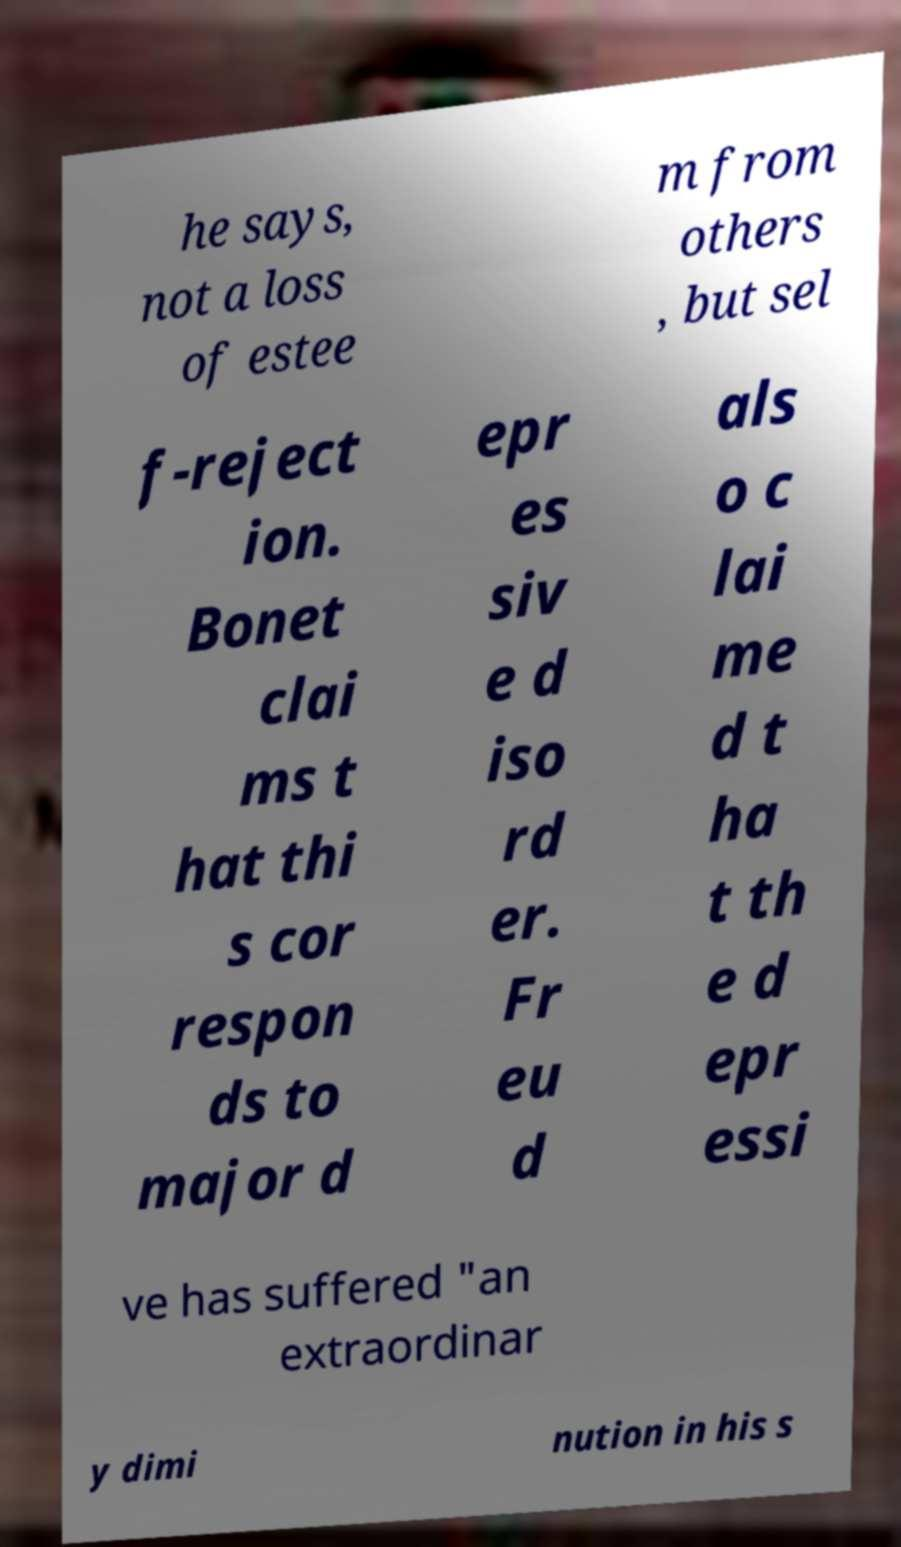Please identify and transcribe the text found in this image. he says, not a loss of estee m from others , but sel f-reject ion. Bonet clai ms t hat thi s cor respon ds to major d epr es siv e d iso rd er. Fr eu d als o c lai me d t ha t th e d epr essi ve has suffered "an extraordinar y dimi nution in his s 